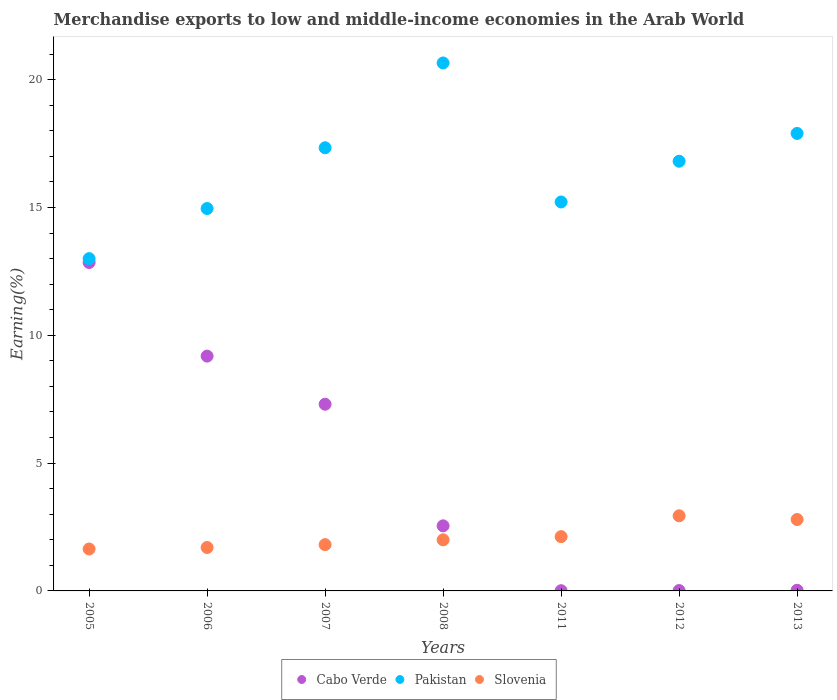Is the number of dotlines equal to the number of legend labels?
Offer a terse response. Yes. What is the percentage of amount earned from merchandise exports in Cabo Verde in 2006?
Provide a short and direct response. 9.18. Across all years, what is the maximum percentage of amount earned from merchandise exports in Pakistan?
Provide a succinct answer. 20.65. Across all years, what is the minimum percentage of amount earned from merchandise exports in Slovenia?
Give a very brief answer. 1.64. What is the total percentage of amount earned from merchandise exports in Slovenia in the graph?
Give a very brief answer. 15. What is the difference between the percentage of amount earned from merchandise exports in Slovenia in 2011 and that in 2013?
Keep it short and to the point. -0.67. What is the difference between the percentage of amount earned from merchandise exports in Pakistan in 2013 and the percentage of amount earned from merchandise exports in Cabo Verde in 2007?
Provide a succinct answer. 10.59. What is the average percentage of amount earned from merchandise exports in Cabo Verde per year?
Provide a short and direct response. 4.56. In the year 2005, what is the difference between the percentage of amount earned from merchandise exports in Cabo Verde and percentage of amount earned from merchandise exports in Slovenia?
Give a very brief answer. 11.21. In how many years, is the percentage of amount earned from merchandise exports in Cabo Verde greater than 9 %?
Provide a short and direct response. 2. What is the ratio of the percentage of amount earned from merchandise exports in Pakistan in 2006 to that in 2012?
Offer a very short reply. 0.89. Is the difference between the percentage of amount earned from merchandise exports in Cabo Verde in 2005 and 2013 greater than the difference between the percentage of amount earned from merchandise exports in Slovenia in 2005 and 2013?
Make the answer very short. Yes. What is the difference between the highest and the second highest percentage of amount earned from merchandise exports in Slovenia?
Provide a short and direct response. 0.15. What is the difference between the highest and the lowest percentage of amount earned from merchandise exports in Slovenia?
Offer a very short reply. 1.3. In how many years, is the percentage of amount earned from merchandise exports in Pakistan greater than the average percentage of amount earned from merchandise exports in Pakistan taken over all years?
Provide a short and direct response. 4. Is the sum of the percentage of amount earned from merchandise exports in Pakistan in 2007 and 2008 greater than the maximum percentage of amount earned from merchandise exports in Cabo Verde across all years?
Give a very brief answer. Yes. Is it the case that in every year, the sum of the percentage of amount earned from merchandise exports in Slovenia and percentage of amount earned from merchandise exports in Cabo Verde  is greater than the percentage of amount earned from merchandise exports in Pakistan?
Provide a succinct answer. No. Is the percentage of amount earned from merchandise exports in Slovenia strictly greater than the percentage of amount earned from merchandise exports in Cabo Verde over the years?
Provide a succinct answer. No. How many dotlines are there?
Ensure brevity in your answer.  3. How many years are there in the graph?
Your response must be concise. 7. What is the difference between two consecutive major ticks on the Y-axis?
Your response must be concise. 5. Are the values on the major ticks of Y-axis written in scientific E-notation?
Give a very brief answer. No. Does the graph contain any zero values?
Offer a terse response. No. How many legend labels are there?
Give a very brief answer. 3. How are the legend labels stacked?
Your response must be concise. Horizontal. What is the title of the graph?
Your response must be concise. Merchandise exports to low and middle-income economies in the Arab World. Does "United States" appear as one of the legend labels in the graph?
Provide a short and direct response. No. What is the label or title of the X-axis?
Your answer should be very brief. Years. What is the label or title of the Y-axis?
Offer a very short reply. Earning(%). What is the Earning(%) in Cabo Verde in 2005?
Give a very brief answer. 12.85. What is the Earning(%) of Pakistan in 2005?
Provide a succinct answer. 13. What is the Earning(%) of Slovenia in 2005?
Make the answer very short. 1.64. What is the Earning(%) of Cabo Verde in 2006?
Your answer should be very brief. 9.18. What is the Earning(%) in Pakistan in 2006?
Offer a terse response. 14.96. What is the Earning(%) of Slovenia in 2006?
Provide a succinct answer. 1.7. What is the Earning(%) of Cabo Verde in 2007?
Your response must be concise. 7.3. What is the Earning(%) of Pakistan in 2007?
Offer a terse response. 17.33. What is the Earning(%) in Slovenia in 2007?
Provide a short and direct response. 1.81. What is the Earning(%) in Cabo Verde in 2008?
Provide a succinct answer. 2.55. What is the Earning(%) in Pakistan in 2008?
Offer a very short reply. 20.65. What is the Earning(%) in Slovenia in 2008?
Provide a short and direct response. 2. What is the Earning(%) of Cabo Verde in 2011?
Ensure brevity in your answer.  0.01. What is the Earning(%) of Pakistan in 2011?
Your answer should be very brief. 15.21. What is the Earning(%) in Slovenia in 2011?
Offer a terse response. 2.12. What is the Earning(%) of Cabo Verde in 2012?
Your answer should be very brief. 0.01. What is the Earning(%) in Pakistan in 2012?
Provide a succinct answer. 16.81. What is the Earning(%) in Slovenia in 2012?
Your answer should be compact. 2.94. What is the Earning(%) in Cabo Verde in 2013?
Your answer should be compact. 0.03. What is the Earning(%) in Pakistan in 2013?
Keep it short and to the point. 17.89. What is the Earning(%) of Slovenia in 2013?
Give a very brief answer. 2.79. Across all years, what is the maximum Earning(%) of Cabo Verde?
Provide a succinct answer. 12.85. Across all years, what is the maximum Earning(%) of Pakistan?
Offer a very short reply. 20.65. Across all years, what is the maximum Earning(%) of Slovenia?
Give a very brief answer. 2.94. Across all years, what is the minimum Earning(%) in Cabo Verde?
Ensure brevity in your answer.  0.01. Across all years, what is the minimum Earning(%) in Pakistan?
Your response must be concise. 13. Across all years, what is the minimum Earning(%) of Slovenia?
Your response must be concise. 1.64. What is the total Earning(%) in Cabo Verde in the graph?
Offer a very short reply. 31.93. What is the total Earning(%) of Pakistan in the graph?
Provide a short and direct response. 115.86. What is the total Earning(%) in Slovenia in the graph?
Provide a short and direct response. 15. What is the difference between the Earning(%) in Cabo Verde in 2005 and that in 2006?
Ensure brevity in your answer.  3.66. What is the difference between the Earning(%) of Pakistan in 2005 and that in 2006?
Make the answer very short. -1.96. What is the difference between the Earning(%) of Slovenia in 2005 and that in 2006?
Ensure brevity in your answer.  -0.06. What is the difference between the Earning(%) of Cabo Verde in 2005 and that in 2007?
Your answer should be compact. 5.54. What is the difference between the Earning(%) of Pakistan in 2005 and that in 2007?
Your answer should be very brief. -4.34. What is the difference between the Earning(%) of Slovenia in 2005 and that in 2007?
Your response must be concise. -0.17. What is the difference between the Earning(%) of Cabo Verde in 2005 and that in 2008?
Your answer should be very brief. 10.3. What is the difference between the Earning(%) of Pakistan in 2005 and that in 2008?
Your answer should be very brief. -7.65. What is the difference between the Earning(%) of Slovenia in 2005 and that in 2008?
Provide a short and direct response. -0.36. What is the difference between the Earning(%) in Cabo Verde in 2005 and that in 2011?
Provide a succinct answer. 12.84. What is the difference between the Earning(%) of Pakistan in 2005 and that in 2011?
Provide a short and direct response. -2.22. What is the difference between the Earning(%) in Slovenia in 2005 and that in 2011?
Provide a succinct answer. -0.48. What is the difference between the Earning(%) of Cabo Verde in 2005 and that in 2012?
Your answer should be very brief. 12.83. What is the difference between the Earning(%) of Pakistan in 2005 and that in 2012?
Make the answer very short. -3.81. What is the difference between the Earning(%) of Slovenia in 2005 and that in 2012?
Offer a very short reply. -1.3. What is the difference between the Earning(%) in Cabo Verde in 2005 and that in 2013?
Provide a succinct answer. 12.82. What is the difference between the Earning(%) in Pakistan in 2005 and that in 2013?
Give a very brief answer. -4.9. What is the difference between the Earning(%) in Slovenia in 2005 and that in 2013?
Provide a short and direct response. -1.15. What is the difference between the Earning(%) of Cabo Verde in 2006 and that in 2007?
Your answer should be compact. 1.88. What is the difference between the Earning(%) of Pakistan in 2006 and that in 2007?
Ensure brevity in your answer.  -2.38. What is the difference between the Earning(%) of Slovenia in 2006 and that in 2007?
Ensure brevity in your answer.  -0.11. What is the difference between the Earning(%) of Cabo Verde in 2006 and that in 2008?
Offer a very short reply. 6.64. What is the difference between the Earning(%) in Pakistan in 2006 and that in 2008?
Give a very brief answer. -5.69. What is the difference between the Earning(%) in Slovenia in 2006 and that in 2008?
Your answer should be very brief. -0.3. What is the difference between the Earning(%) of Cabo Verde in 2006 and that in 2011?
Offer a terse response. 9.18. What is the difference between the Earning(%) in Pakistan in 2006 and that in 2011?
Give a very brief answer. -0.26. What is the difference between the Earning(%) of Slovenia in 2006 and that in 2011?
Keep it short and to the point. -0.42. What is the difference between the Earning(%) in Cabo Verde in 2006 and that in 2012?
Offer a very short reply. 9.17. What is the difference between the Earning(%) of Pakistan in 2006 and that in 2012?
Provide a succinct answer. -1.85. What is the difference between the Earning(%) in Slovenia in 2006 and that in 2012?
Ensure brevity in your answer.  -1.24. What is the difference between the Earning(%) of Cabo Verde in 2006 and that in 2013?
Your answer should be compact. 9.16. What is the difference between the Earning(%) in Pakistan in 2006 and that in 2013?
Ensure brevity in your answer.  -2.94. What is the difference between the Earning(%) of Slovenia in 2006 and that in 2013?
Ensure brevity in your answer.  -1.1. What is the difference between the Earning(%) of Cabo Verde in 2007 and that in 2008?
Ensure brevity in your answer.  4.76. What is the difference between the Earning(%) of Pakistan in 2007 and that in 2008?
Your answer should be compact. -3.32. What is the difference between the Earning(%) of Slovenia in 2007 and that in 2008?
Ensure brevity in your answer.  -0.19. What is the difference between the Earning(%) in Cabo Verde in 2007 and that in 2011?
Provide a succinct answer. 7.29. What is the difference between the Earning(%) of Pakistan in 2007 and that in 2011?
Offer a very short reply. 2.12. What is the difference between the Earning(%) in Slovenia in 2007 and that in 2011?
Give a very brief answer. -0.31. What is the difference between the Earning(%) in Cabo Verde in 2007 and that in 2012?
Keep it short and to the point. 7.29. What is the difference between the Earning(%) in Pakistan in 2007 and that in 2012?
Offer a terse response. 0.53. What is the difference between the Earning(%) in Slovenia in 2007 and that in 2012?
Your response must be concise. -1.13. What is the difference between the Earning(%) in Cabo Verde in 2007 and that in 2013?
Your response must be concise. 7.28. What is the difference between the Earning(%) of Pakistan in 2007 and that in 2013?
Ensure brevity in your answer.  -0.56. What is the difference between the Earning(%) in Slovenia in 2007 and that in 2013?
Keep it short and to the point. -0.98. What is the difference between the Earning(%) in Cabo Verde in 2008 and that in 2011?
Your answer should be very brief. 2.54. What is the difference between the Earning(%) in Pakistan in 2008 and that in 2011?
Your response must be concise. 5.44. What is the difference between the Earning(%) in Slovenia in 2008 and that in 2011?
Offer a very short reply. -0.12. What is the difference between the Earning(%) in Cabo Verde in 2008 and that in 2012?
Your answer should be compact. 2.53. What is the difference between the Earning(%) of Pakistan in 2008 and that in 2012?
Ensure brevity in your answer.  3.84. What is the difference between the Earning(%) of Slovenia in 2008 and that in 2012?
Your answer should be very brief. -0.94. What is the difference between the Earning(%) in Cabo Verde in 2008 and that in 2013?
Offer a terse response. 2.52. What is the difference between the Earning(%) of Pakistan in 2008 and that in 2013?
Provide a succinct answer. 2.76. What is the difference between the Earning(%) of Slovenia in 2008 and that in 2013?
Provide a succinct answer. -0.79. What is the difference between the Earning(%) in Cabo Verde in 2011 and that in 2012?
Your answer should be very brief. -0.01. What is the difference between the Earning(%) of Pakistan in 2011 and that in 2012?
Offer a very short reply. -1.59. What is the difference between the Earning(%) in Slovenia in 2011 and that in 2012?
Your answer should be compact. -0.82. What is the difference between the Earning(%) in Cabo Verde in 2011 and that in 2013?
Give a very brief answer. -0.02. What is the difference between the Earning(%) of Pakistan in 2011 and that in 2013?
Provide a succinct answer. -2.68. What is the difference between the Earning(%) in Slovenia in 2011 and that in 2013?
Provide a succinct answer. -0.67. What is the difference between the Earning(%) of Cabo Verde in 2012 and that in 2013?
Your answer should be very brief. -0.01. What is the difference between the Earning(%) of Pakistan in 2012 and that in 2013?
Your response must be concise. -1.09. What is the difference between the Earning(%) in Slovenia in 2012 and that in 2013?
Give a very brief answer. 0.15. What is the difference between the Earning(%) in Cabo Verde in 2005 and the Earning(%) in Pakistan in 2006?
Offer a terse response. -2.11. What is the difference between the Earning(%) of Cabo Verde in 2005 and the Earning(%) of Slovenia in 2006?
Provide a succinct answer. 11.15. What is the difference between the Earning(%) in Pakistan in 2005 and the Earning(%) in Slovenia in 2006?
Offer a very short reply. 11.3. What is the difference between the Earning(%) of Cabo Verde in 2005 and the Earning(%) of Pakistan in 2007?
Make the answer very short. -4.49. What is the difference between the Earning(%) of Cabo Verde in 2005 and the Earning(%) of Slovenia in 2007?
Give a very brief answer. 11.04. What is the difference between the Earning(%) of Pakistan in 2005 and the Earning(%) of Slovenia in 2007?
Give a very brief answer. 11.19. What is the difference between the Earning(%) in Cabo Verde in 2005 and the Earning(%) in Pakistan in 2008?
Provide a short and direct response. -7.81. What is the difference between the Earning(%) of Cabo Verde in 2005 and the Earning(%) of Slovenia in 2008?
Keep it short and to the point. 10.85. What is the difference between the Earning(%) of Pakistan in 2005 and the Earning(%) of Slovenia in 2008?
Offer a terse response. 11. What is the difference between the Earning(%) in Cabo Verde in 2005 and the Earning(%) in Pakistan in 2011?
Offer a very short reply. -2.37. What is the difference between the Earning(%) in Cabo Verde in 2005 and the Earning(%) in Slovenia in 2011?
Give a very brief answer. 10.72. What is the difference between the Earning(%) in Pakistan in 2005 and the Earning(%) in Slovenia in 2011?
Keep it short and to the point. 10.87. What is the difference between the Earning(%) in Cabo Verde in 2005 and the Earning(%) in Pakistan in 2012?
Ensure brevity in your answer.  -3.96. What is the difference between the Earning(%) in Cabo Verde in 2005 and the Earning(%) in Slovenia in 2012?
Your response must be concise. 9.91. What is the difference between the Earning(%) in Pakistan in 2005 and the Earning(%) in Slovenia in 2012?
Keep it short and to the point. 10.06. What is the difference between the Earning(%) of Cabo Verde in 2005 and the Earning(%) of Pakistan in 2013?
Keep it short and to the point. -5.05. What is the difference between the Earning(%) of Cabo Verde in 2005 and the Earning(%) of Slovenia in 2013?
Make the answer very short. 10.05. What is the difference between the Earning(%) of Pakistan in 2005 and the Earning(%) of Slovenia in 2013?
Your answer should be very brief. 10.2. What is the difference between the Earning(%) of Cabo Verde in 2006 and the Earning(%) of Pakistan in 2007?
Offer a terse response. -8.15. What is the difference between the Earning(%) in Cabo Verde in 2006 and the Earning(%) in Slovenia in 2007?
Offer a terse response. 7.37. What is the difference between the Earning(%) in Pakistan in 2006 and the Earning(%) in Slovenia in 2007?
Ensure brevity in your answer.  13.15. What is the difference between the Earning(%) of Cabo Verde in 2006 and the Earning(%) of Pakistan in 2008?
Provide a short and direct response. -11.47. What is the difference between the Earning(%) in Cabo Verde in 2006 and the Earning(%) in Slovenia in 2008?
Offer a terse response. 7.19. What is the difference between the Earning(%) of Pakistan in 2006 and the Earning(%) of Slovenia in 2008?
Offer a terse response. 12.96. What is the difference between the Earning(%) of Cabo Verde in 2006 and the Earning(%) of Pakistan in 2011?
Make the answer very short. -6.03. What is the difference between the Earning(%) in Cabo Verde in 2006 and the Earning(%) in Slovenia in 2011?
Provide a short and direct response. 7.06. What is the difference between the Earning(%) of Pakistan in 2006 and the Earning(%) of Slovenia in 2011?
Your response must be concise. 12.83. What is the difference between the Earning(%) in Cabo Verde in 2006 and the Earning(%) in Pakistan in 2012?
Your response must be concise. -7.62. What is the difference between the Earning(%) in Cabo Verde in 2006 and the Earning(%) in Slovenia in 2012?
Provide a short and direct response. 6.25. What is the difference between the Earning(%) of Pakistan in 2006 and the Earning(%) of Slovenia in 2012?
Your answer should be compact. 12.02. What is the difference between the Earning(%) of Cabo Verde in 2006 and the Earning(%) of Pakistan in 2013?
Offer a very short reply. -8.71. What is the difference between the Earning(%) of Cabo Verde in 2006 and the Earning(%) of Slovenia in 2013?
Give a very brief answer. 6.39. What is the difference between the Earning(%) in Pakistan in 2006 and the Earning(%) in Slovenia in 2013?
Ensure brevity in your answer.  12.16. What is the difference between the Earning(%) in Cabo Verde in 2007 and the Earning(%) in Pakistan in 2008?
Ensure brevity in your answer.  -13.35. What is the difference between the Earning(%) in Cabo Verde in 2007 and the Earning(%) in Slovenia in 2008?
Offer a very short reply. 5.3. What is the difference between the Earning(%) in Pakistan in 2007 and the Earning(%) in Slovenia in 2008?
Your answer should be very brief. 15.34. What is the difference between the Earning(%) in Cabo Verde in 2007 and the Earning(%) in Pakistan in 2011?
Ensure brevity in your answer.  -7.91. What is the difference between the Earning(%) of Cabo Verde in 2007 and the Earning(%) of Slovenia in 2011?
Ensure brevity in your answer.  5.18. What is the difference between the Earning(%) of Pakistan in 2007 and the Earning(%) of Slovenia in 2011?
Give a very brief answer. 15.21. What is the difference between the Earning(%) of Cabo Verde in 2007 and the Earning(%) of Pakistan in 2012?
Ensure brevity in your answer.  -9.5. What is the difference between the Earning(%) of Cabo Verde in 2007 and the Earning(%) of Slovenia in 2012?
Ensure brevity in your answer.  4.36. What is the difference between the Earning(%) in Pakistan in 2007 and the Earning(%) in Slovenia in 2012?
Provide a short and direct response. 14.4. What is the difference between the Earning(%) in Cabo Verde in 2007 and the Earning(%) in Pakistan in 2013?
Your response must be concise. -10.59. What is the difference between the Earning(%) in Cabo Verde in 2007 and the Earning(%) in Slovenia in 2013?
Offer a very short reply. 4.51. What is the difference between the Earning(%) of Pakistan in 2007 and the Earning(%) of Slovenia in 2013?
Your response must be concise. 14.54. What is the difference between the Earning(%) of Cabo Verde in 2008 and the Earning(%) of Pakistan in 2011?
Make the answer very short. -12.67. What is the difference between the Earning(%) in Cabo Verde in 2008 and the Earning(%) in Slovenia in 2011?
Give a very brief answer. 0.42. What is the difference between the Earning(%) of Pakistan in 2008 and the Earning(%) of Slovenia in 2011?
Keep it short and to the point. 18.53. What is the difference between the Earning(%) in Cabo Verde in 2008 and the Earning(%) in Pakistan in 2012?
Your response must be concise. -14.26. What is the difference between the Earning(%) of Cabo Verde in 2008 and the Earning(%) of Slovenia in 2012?
Offer a very short reply. -0.39. What is the difference between the Earning(%) in Pakistan in 2008 and the Earning(%) in Slovenia in 2012?
Offer a very short reply. 17.71. What is the difference between the Earning(%) of Cabo Verde in 2008 and the Earning(%) of Pakistan in 2013?
Make the answer very short. -15.35. What is the difference between the Earning(%) of Cabo Verde in 2008 and the Earning(%) of Slovenia in 2013?
Give a very brief answer. -0.25. What is the difference between the Earning(%) in Pakistan in 2008 and the Earning(%) in Slovenia in 2013?
Provide a succinct answer. 17.86. What is the difference between the Earning(%) in Cabo Verde in 2011 and the Earning(%) in Pakistan in 2012?
Offer a very short reply. -16.8. What is the difference between the Earning(%) of Cabo Verde in 2011 and the Earning(%) of Slovenia in 2012?
Ensure brevity in your answer.  -2.93. What is the difference between the Earning(%) of Pakistan in 2011 and the Earning(%) of Slovenia in 2012?
Make the answer very short. 12.28. What is the difference between the Earning(%) of Cabo Verde in 2011 and the Earning(%) of Pakistan in 2013?
Offer a terse response. -17.89. What is the difference between the Earning(%) of Cabo Verde in 2011 and the Earning(%) of Slovenia in 2013?
Make the answer very short. -2.79. What is the difference between the Earning(%) of Pakistan in 2011 and the Earning(%) of Slovenia in 2013?
Your answer should be compact. 12.42. What is the difference between the Earning(%) of Cabo Verde in 2012 and the Earning(%) of Pakistan in 2013?
Your response must be concise. -17.88. What is the difference between the Earning(%) in Cabo Verde in 2012 and the Earning(%) in Slovenia in 2013?
Keep it short and to the point. -2.78. What is the difference between the Earning(%) of Pakistan in 2012 and the Earning(%) of Slovenia in 2013?
Keep it short and to the point. 14.01. What is the average Earning(%) in Cabo Verde per year?
Your answer should be very brief. 4.56. What is the average Earning(%) in Pakistan per year?
Give a very brief answer. 16.55. What is the average Earning(%) in Slovenia per year?
Offer a very short reply. 2.14. In the year 2005, what is the difference between the Earning(%) in Cabo Verde and Earning(%) in Pakistan?
Provide a short and direct response. -0.15. In the year 2005, what is the difference between the Earning(%) of Cabo Verde and Earning(%) of Slovenia?
Offer a terse response. 11.21. In the year 2005, what is the difference between the Earning(%) in Pakistan and Earning(%) in Slovenia?
Your answer should be compact. 11.36. In the year 2006, what is the difference between the Earning(%) in Cabo Verde and Earning(%) in Pakistan?
Provide a succinct answer. -5.77. In the year 2006, what is the difference between the Earning(%) of Cabo Verde and Earning(%) of Slovenia?
Give a very brief answer. 7.49. In the year 2006, what is the difference between the Earning(%) of Pakistan and Earning(%) of Slovenia?
Your answer should be very brief. 13.26. In the year 2007, what is the difference between the Earning(%) in Cabo Verde and Earning(%) in Pakistan?
Keep it short and to the point. -10.03. In the year 2007, what is the difference between the Earning(%) of Cabo Verde and Earning(%) of Slovenia?
Your response must be concise. 5.49. In the year 2007, what is the difference between the Earning(%) in Pakistan and Earning(%) in Slovenia?
Make the answer very short. 15.52. In the year 2008, what is the difference between the Earning(%) in Cabo Verde and Earning(%) in Pakistan?
Make the answer very short. -18.11. In the year 2008, what is the difference between the Earning(%) of Cabo Verde and Earning(%) of Slovenia?
Keep it short and to the point. 0.55. In the year 2008, what is the difference between the Earning(%) of Pakistan and Earning(%) of Slovenia?
Give a very brief answer. 18.65. In the year 2011, what is the difference between the Earning(%) in Cabo Verde and Earning(%) in Pakistan?
Your response must be concise. -15.21. In the year 2011, what is the difference between the Earning(%) of Cabo Verde and Earning(%) of Slovenia?
Your answer should be compact. -2.12. In the year 2011, what is the difference between the Earning(%) in Pakistan and Earning(%) in Slovenia?
Offer a terse response. 13.09. In the year 2012, what is the difference between the Earning(%) of Cabo Verde and Earning(%) of Pakistan?
Offer a terse response. -16.79. In the year 2012, what is the difference between the Earning(%) of Cabo Verde and Earning(%) of Slovenia?
Make the answer very short. -2.93. In the year 2012, what is the difference between the Earning(%) in Pakistan and Earning(%) in Slovenia?
Your answer should be compact. 13.87. In the year 2013, what is the difference between the Earning(%) of Cabo Verde and Earning(%) of Pakistan?
Your answer should be very brief. -17.87. In the year 2013, what is the difference between the Earning(%) of Cabo Verde and Earning(%) of Slovenia?
Give a very brief answer. -2.77. In the year 2013, what is the difference between the Earning(%) of Pakistan and Earning(%) of Slovenia?
Offer a very short reply. 15.1. What is the ratio of the Earning(%) of Cabo Verde in 2005 to that in 2006?
Make the answer very short. 1.4. What is the ratio of the Earning(%) in Pakistan in 2005 to that in 2006?
Offer a very short reply. 0.87. What is the ratio of the Earning(%) in Slovenia in 2005 to that in 2006?
Ensure brevity in your answer.  0.97. What is the ratio of the Earning(%) in Cabo Verde in 2005 to that in 2007?
Offer a terse response. 1.76. What is the ratio of the Earning(%) in Pakistan in 2005 to that in 2007?
Offer a terse response. 0.75. What is the ratio of the Earning(%) in Slovenia in 2005 to that in 2007?
Ensure brevity in your answer.  0.91. What is the ratio of the Earning(%) of Cabo Verde in 2005 to that in 2008?
Your answer should be very brief. 5.05. What is the ratio of the Earning(%) in Pakistan in 2005 to that in 2008?
Keep it short and to the point. 0.63. What is the ratio of the Earning(%) of Slovenia in 2005 to that in 2008?
Offer a very short reply. 0.82. What is the ratio of the Earning(%) in Cabo Verde in 2005 to that in 2011?
Provide a short and direct response. 1542.81. What is the ratio of the Earning(%) in Pakistan in 2005 to that in 2011?
Make the answer very short. 0.85. What is the ratio of the Earning(%) of Slovenia in 2005 to that in 2011?
Give a very brief answer. 0.77. What is the ratio of the Earning(%) of Cabo Verde in 2005 to that in 2012?
Offer a terse response. 938.94. What is the ratio of the Earning(%) of Pakistan in 2005 to that in 2012?
Offer a terse response. 0.77. What is the ratio of the Earning(%) in Slovenia in 2005 to that in 2012?
Keep it short and to the point. 0.56. What is the ratio of the Earning(%) in Cabo Verde in 2005 to that in 2013?
Provide a short and direct response. 507.34. What is the ratio of the Earning(%) of Pakistan in 2005 to that in 2013?
Provide a short and direct response. 0.73. What is the ratio of the Earning(%) of Slovenia in 2005 to that in 2013?
Provide a succinct answer. 0.59. What is the ratio of the Earning(%) in Cabo Verde in 2006 to that in 2007?
Provide a succinct answer. 1.26. What is the ratio of the Earning(%) of Pakistan in 2006 to that in 2007?
Offer a very short reply. 0.86. What is the ratio of the Earning(%) of Slovenia in 2006 to that in 2007?
Give a very brief answer. 0.94. What is the ratio of the Earning(%) in Cabo Verde in 2006 to that in 2008?
Offer a very short reply. 3.61. What is the ratio of the Earning(%) in Pakistan in 2006 to that in 2008?
Make the answer very short. 0.72. What is the ratio of the Earning(%) in Slovenia in 2006 to that in 2008?
Offer a very short reply. 0.85. What is the ratio of the Earning(%) of Cabo Verde in 2006 to that in 2011?
Your answer should be very brief. 1103.05. What is the ratio of the Earning(%) of Pakistan in 2006 to that in 2011?
Give a very brief answer. 0.98. What is the ratio of the Earning(%) in Slovenia in 2006 to that in 2011?
Ensure brevity in your answer.  0.8. What is the ratio of the Earning(%) in Cabo Verde in 2006 to that in 2012?
Keep it short and to the point. 671.31. What is the ratio of the Earning(%) of Pakistan in 2006 to that in 2012?
Ensure brevity in your answer.  0.89. What is the ratio of the Earning(%) in Slovenia in 2006 to that in 2012?
Provide a short and direct response. 0.58. What is the ratio of the Earning(%) of Cabo Verde in 2006 to that in 2013?
Offer a terse response. 362.73. What is the ratio of the Earning(%) in Pakistan in 2006 to that in 2013?
Provide a short and direct response. 0.84. What is the ratio of the Earning(%) in Slovenia in 2006 to that in 2013?
Provide a succinct answer. 0.61. What is the ratio of the Earning(%) of Cabo Verde in 2007 to that in 2008?
Make the answer very short. 2.87. What is the ratio of the Earning(%) in Pakistan in 2007 to that in 2008?
Your response must be concise. 0.84. What is the ratio of the Earning(%) of Slovenia in 2007 to that in 2008?
Provide a short and direct response. 0.91. What is the ratio of the Earning(%) in Cabo Verde in 2007 to that in 2011?
Your answer should be compact. 877.03. What is the ratio of the Earning(%) of Pakistan in 2007 to that in 2011?
Ensure brevity in your answer.  1.14. What is the ratio of the Earning(%) in Slovenia in 2007 to that in 2011?
Your answer should be very brief. 0.85. What is the ratio of the Earning(%) of Cabo Verde in 2007 to that in 2012?
Provide a short and direct response. 533.76. What is the ratio of the Earning(%) of Pakistan in 2007 to that in 2012?
Offer a very short reply. 1.03. What is the ratio of the Earning(%) of Slovenia in 2007 to that in 2012?
Give a very brief answer. 0.62. What is the ratio of the Earning(%) of Cabo Verde in 2007 to that in 2013?
Offer a terse response. 288.41. What is the ratio of the Earning(%) in Pakistan in 2007 to that in 2013?
Your response must be concise. 0.97. What is the ratio of the Earning(%) of Slovenia in 2007 to that in 2013?
Offer a very short reply. 0.65. What is the ratio of the Earning(%) of Cabo Verde in 2008 to that in 2011?
Make the answer very short. 305.77. What is the ratio of the Earning(%) in Pakistan in 2008 to that in 2011?
Provide a short and direct response. 1.36. What is the ratio of the Earning(%) of Slovenia in 2008 to that in 2011?
Your answer should be very brief. 0.94. What is the ratio of the Earning(%) of Cabo Verde in 2008 to that in 2012?
Give a very brief answer. 186.09. What is the ratio of the Earning(%) in Pakistan in 2008 to that in 2012?
Give a very brief answer. 1.23. What is the ratio of the Earning(%) of Slovenia in 2008 to that in 2012?
Your response must be concise. 0.68. What is the ratio of the Earning(%) of Cabo Verde in 2008 to that in 2013?
Offer a very short reply. 100.55. What is the ratio of the Earning(%) in Pakistan in 2008 to that in 2013?
Ensure brevity in your answer.  1.15. What is the ratio of the Earning(%) in Slovenia in 2008 to that in 2013?
Offer a terse response. 0.72. What is the ratio of the Earning(%) of Cabo Verde in 2011 to that in 2012?
Give a very brief answer. 0.61. What is the ratio of the Earning(%) of Pakistan in 2011 to that in 2012?
Provide a succinct answer. 0.91. What is the ratio of the Earning(%) of Slovenia in 2011 to that in 2012?
Offer a terse response. 0.72. What is the ratio of the Earning(%) in Cabo Verde in 2011 to that in 2013?
Provide a succinct answer. 0.33. What is the ratio of the Earning(%) of Pakistan in 2011 to that in 2013?
Make the answer very short. 0.85. What is the ratio of the Earning(%) of Slovenia in 2011 to that in 2013?
Offer a terse response. 0.76. What is the ratio of the Earning(%) in Cabo Verde in 2012 to that in 2013?
Make the answer very short. 0.54. What is the ratio of the Earning(%) in Pakistan in 2012 to that in 2013?
Ensure brevity in your answer.  0.94. What is the ratio of the Earning(%) of Slovenia in 2012 to that in 2013?
Provide a succinct answer. 1.05. What is the difference between the highest and the second highest Earning(%) of Cabo Verde?
Your answer should be compact. 3.66. What is the difference between the highest and the second highest Earning(%) of Pakistan?
Provide a succinct answer. 2.76. What is the difference between the highest and the second highest Earning(%) of Slovenia?
Provide a short and direct response. 0.15. What is the difference between the highest and the lowest Earning(%) in Cabo Verde?
Offer a very short reply. 12.84. What is the difference between the highest and the lowest Earning(%) in Pakistan?
Keep it short and to the point. 7.65. What is the difference between the highest and the lowest Earning(%) in Slovenia?
Provide a succinct answer. 1.3. 